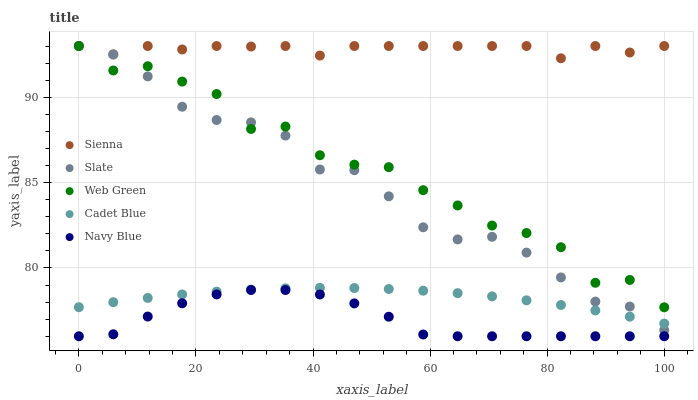Does Navy Blue have the minimum area under the curve?
Answer yes or no. Yes. Does Sienna have the maximum area under the curve?
Answer yes or no. Yes. Does Slate have the minimum area under the curve?
Answer yes or no. No. Does Slate have the maximum area under the curve?
Answer yes or no. No. Is Cadet Blue the smoothest?
Answer yes or no. Yes. Is Web Green the roughest?
Answer yes or no. Yes. Is Navy Blue the smoothest?
Answer yes or no. No. Is Navy Blue the roughest?
Answer yes or no. No. Does Navy Blue have the lowest value?
Answer yes or no. Yes. Does Slate have the lowest value?
Answer yes or no. No. Does Web Green have the highest value?
Answer yes or no. Yes. Does Navy Blue have the highest value?
Answer yes or no. No. Is Cadet Blue less than Web Green?
Answer yes or no. Yes. Is Web Green greater than Cadet Blue?
Answer yes or no. Yes. Does Slate intersect Sienna?
Answer yes or no. Yes. Is Slate less than Sienna?
Answer yes or no. No. Is Slate greater than Sienna?
Answer yes or no. No. Does Cadet Blue intersect Web Green?
Answer yes or no. No. 